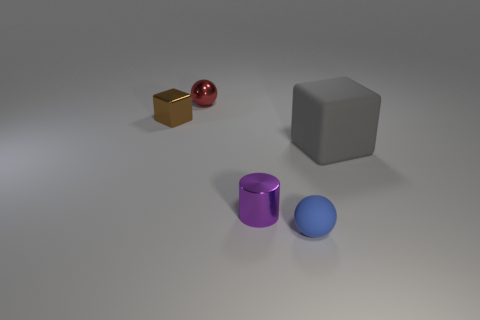What number of red objects are either matte objects or tiny cubes?
Give a very brief answer. 0. Do the tiny sphere that is left of the small blue sphere and the tiny rubber thing have the same color?
Provide a succinct answer. No. What is the size of the rubber thing that is on the left side of the block that is right of the small red sphere?
Give a very brief answer. Small. There is a brown thing that is the same size as the shiny cylinder; what is its material?
Ensure brevity in your answer.  Metal. How many other objects are there of the same size as the gray thing?
Keep it short and to the point. 0. What number of cylinders are brown metal objects or gray matte objects?
Provide a short and direct response. 0. Is there anything else that has the same material as the small blue sphere?
Offer a very short reply. Yes. What material is the block right of the cube that is behind the matte object that is on the right side of the small blue ball?
Provide a short and direct response. Rubber. How many tiny purple cylinders are the same material as the small blue ball?
Your answer should be very brief. 0. Does the sphere behind the brown metal object have the same size as the small purple metal cylinder?
Your answer should be compact. Yes. 